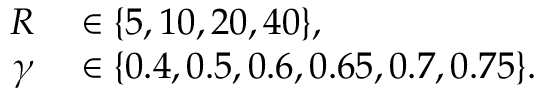<formula> <loc_0><loc_0><loc_500><loc_500>\begin{array} { r l } { R } & \in \{ 5 , 1 0 , 2 0 , 4 0 \} , } \\ { \gamma } & \in \{ 0 . 4 , 0 . 5 , 0 . 6 , 0 . 6 5 , 0 . 7 , 0 . 7 5 \} . } \end{array}</formula> 